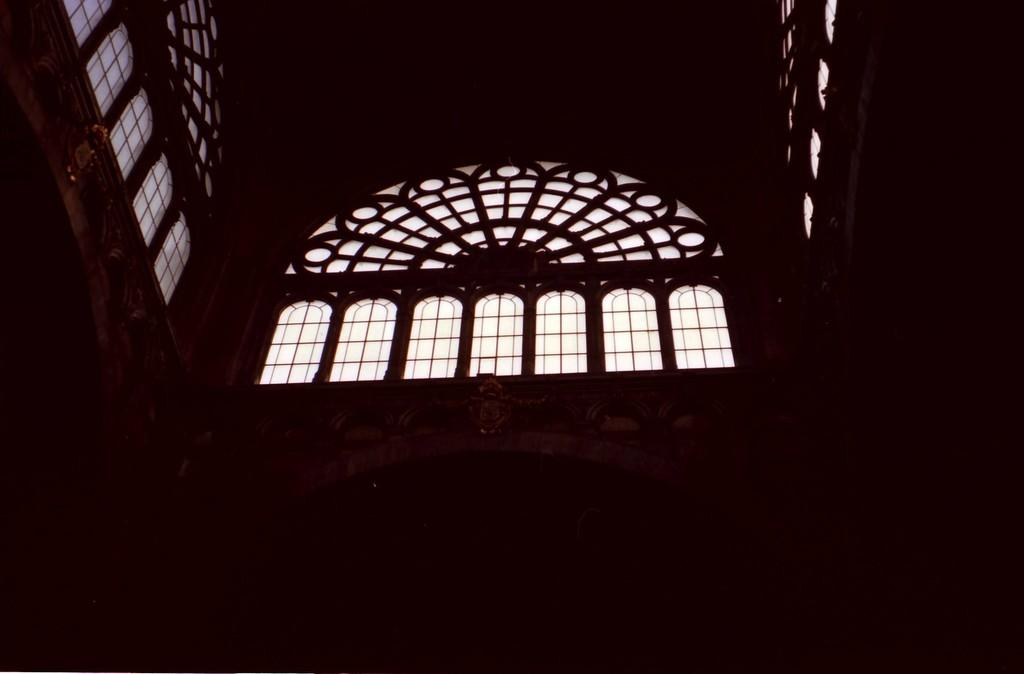What is the lighting condition in the room depicted in the image? The room in the image is dark. How many walls are visible in the room? There are three walls in the room. What feature is present on each wall? Each wall has a window at the top. Are there any decorative elements on the walls? Yes, some parts of the walls have a designed pattern. How many steps does the expert take to reach the aunt in the image? There is no mention of an expert, an aunt, or any steps in the image. 